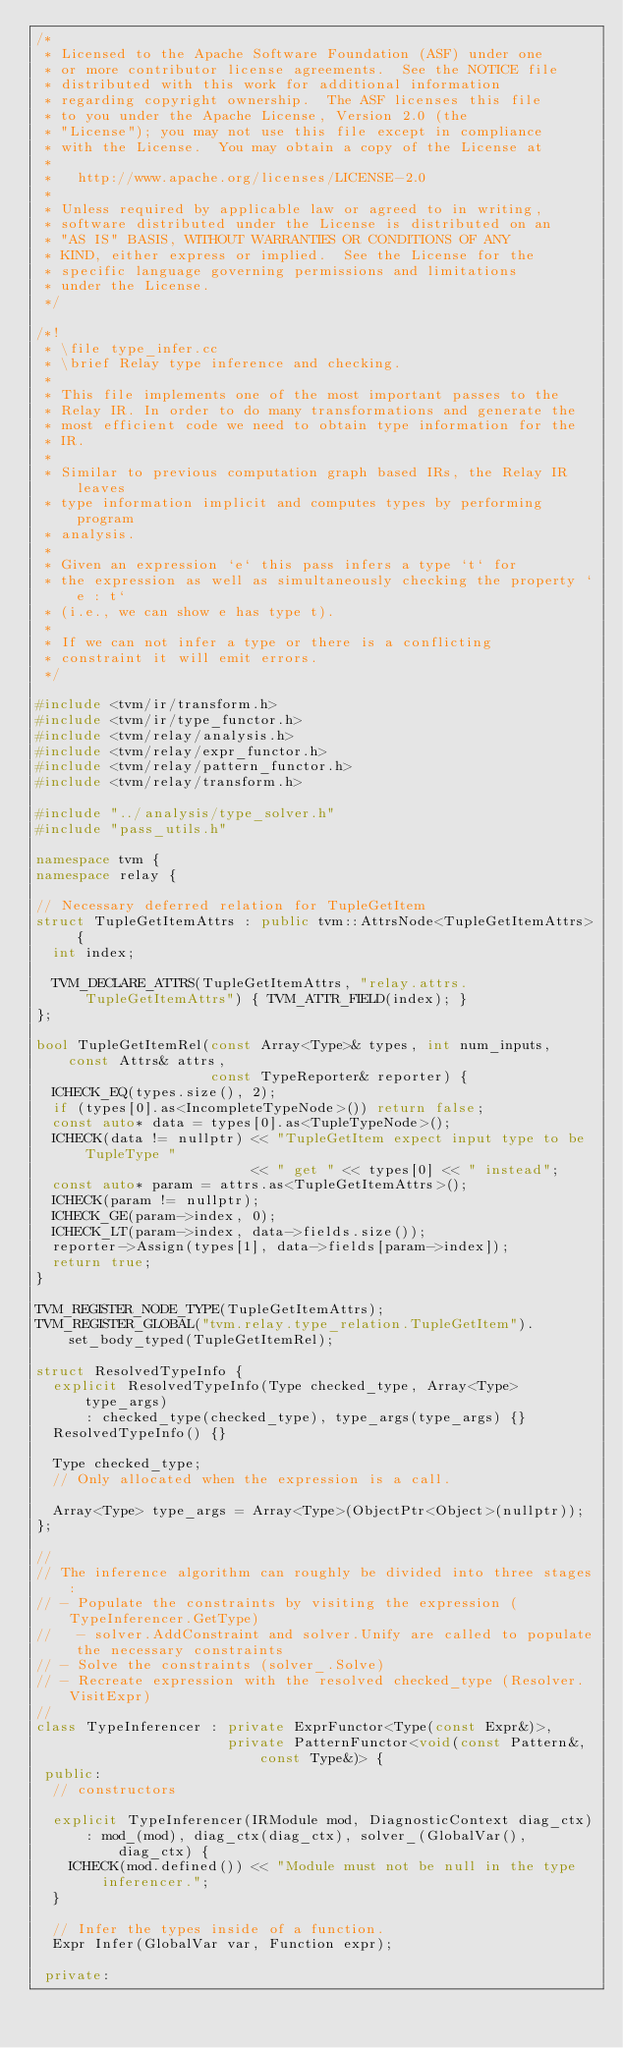<code> <loc_0><loc_0><loc_500><loc_500><_C++_>/*
 * Licensed to the Apache Software Foundation (ASF) under one
 * or more contributor license agreements.  See the NOTICE file
 * distributed with this work for additional information
 * regarding copyright ownership.  The ASF licenses this file
 * to you under the Apache License, Version 2.0 (the
 * "License"); you may not use this file except in compliance
 * with the License.  You may obtain a copy of the License at
 *
 *   http://www.apache.org/licenses/LICENSE-2.0
 *
 * Unless required by applicable law or agreed to in writing,
 * software distributed under the License is distributed on an
 * "AS IS" BASIS, WITHOUT WARRANTIES OR CONDITIONS OF ANY
 * KIND, either express or implied.  See the License for the
 * specific language governing permissions and limitations
 * under the License.
 */

/*!
 * \file type_infer.cc
 * \brief Relay type inference and checking.
 *
 * This file implements one of the most important passes to the
 * Relay IR. In order to do many transformations and generate the
 * most efficient code we need to obtain type information for the
 * IR.
 *
 * Similar to previous computation graph based IRs, the Relay IR leaves
 * type information implicit and computes types by performing program
 * analysis.
 *
 * Given an expression `e` this pass infers a type `t` for
 * the expression as well as simultaneously checking the property `e : t`
 * (i.e., we can show e has type t).
 *
 * If we can not infer a type or there is a conflicting
 * constraint it will emit errors.
 */

#include <tvm/ir/transform.h>
#include <tvm/ir/type_functor.h>
#include <tvm/relay/analysis.h>
#include <tvm/relay/expr_functor.h>
#include <tvm/relay/pattern_functor.h>
#include <tvm/relay/transform.h>

#include "../analysis/type_solver.h"
#include "pass_utils.h"

namespace tvm {
namespace relay {

// Necessary deferred relation for TupleGetItem
struct TupleGetItemAttrs : public tvm::AttrsNode<TupleGetItemAttrs> {
  int index;

  TVM_DECLARE_ATTRS(TupleGetItemAttrs, "relay.attrs.TupleGetItemAttrs") { TVM_ATTR_FIELD(index); }
};

bool TupleGetItemRel(const Array<Type>& types, int num_inputs, const Attrs& attrs,
                     const TypeReporter& reporter) {
  ICHECK_EQ(types.size(), 2);
  if (types[0].as<IncompleteTypeNode>()) return false;
  const auto* data = types[0].as<TupleTypeNode>();
  ICHECK(data != nullptr) << "TupleGetItem expect input type to be TupleType "
                          << " get " << types[0] << " instead";
  const auto* param = attrs.as<TupleGetItemAttrs>();
  ICHECK(param != nullptr);
  ICHECK_GE(param->index, 0);
  ICHECK_LT(param->index, data->fields.size());
  reporter->Assign(types[1], data->fields[param->index]);
  return true;
}

TVM_REGISTER_NODE_TYPE(TupleGetItemAttrs);
TVM_REGISTER_GLOBAL("tvm.relay.type_relation.TupleGetItem").set_body_typed(TupleGetItemRel);

struct ResolvedTypeInfo {
  explicit ResolvedTypeInfo(Type checked_type, Array<Type> type_args)
      : checked_type(checked_type), type_args(type_args) {}
  ResolvedTypeInfo() {}

  Type checked_type;
  // Only allocated when the expression is a call.

  Array<Type> type_args = Array<Type>(ObjectPtr<Object>(nullptr));
};

//
// The inference algorithm can roughly be divided into three stages:
// - Populate the constraints by visiting the expression (TypeInferencer.GetType)
//   - solver.AddConstraint and solver.Unify are called to populate the necessary constraints
// - Solve the constraints (solver_.Solve)
// - Recreate expression with the resolved checked_type (Resolver.VisitExpr)
//
class TypeInferencer : private ExprFunctor<Type(const Expr&)>,
                       private PatternFunctor<void(const Pattern&, const Type&)> {
 public:
  // constructors

  explicit TypeInferencer(IRModule mod, DiagnosticContext diag_ctx)
      : mod_(mod), diag_ctx(diag_ctx), solver_(GlobalVar(), diag_ctx) {
    ICHECK(mod.defined()) << "Module must not be null in the type inferencer.";
  }

  // Infer the types inside of a function.
  Expr Infer(GlobalVar var, Function expr);

 private:</code> 